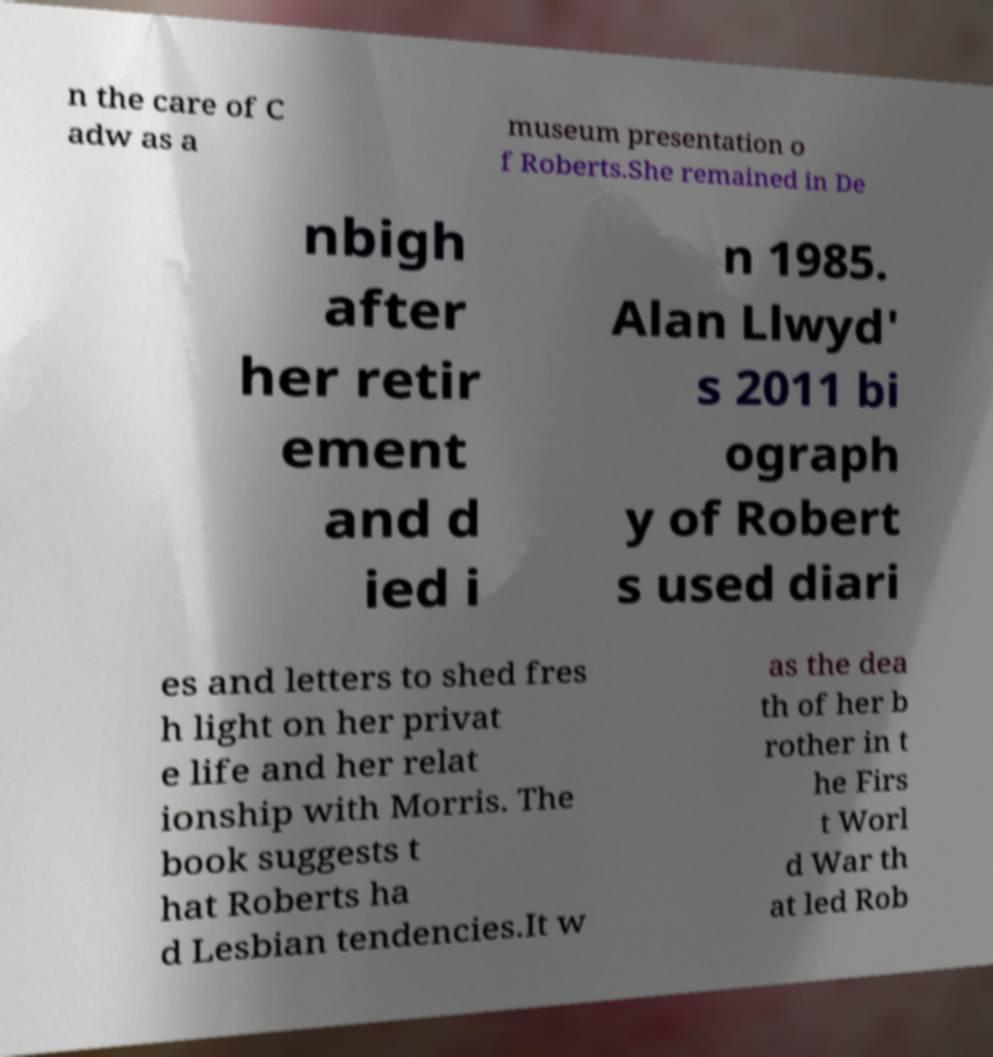Please identify and transcribe the text found in this image. n the care of C adw as a museum presentation o f Roberts.She remained in De nbigh after her retir ement and d ied i n 1985. Alan Llwyd' s 2011 bi ograph y of Robert s used diari es and letters to shed fres h light on her privat e life and her relat ionship with Morris. The book suggests t hat Roberts ha d Lesbian tendencies.It w as the dea th of her b rother in t he Firs t Worl d War th at led Rob 